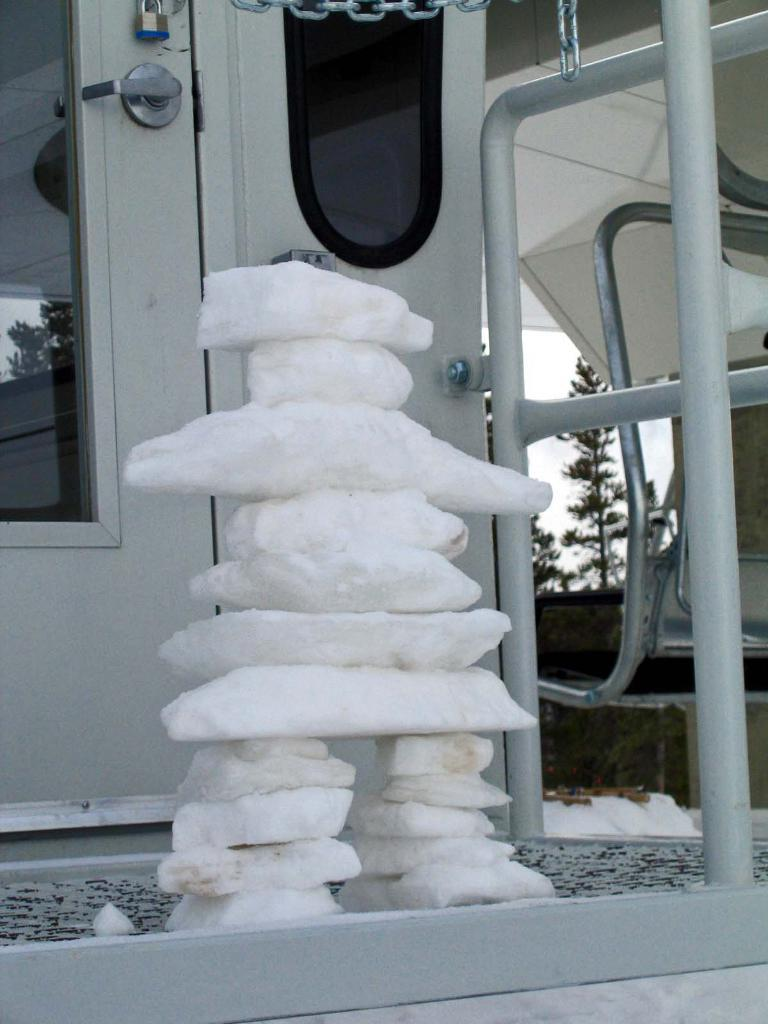What type of structure is visible in the image? There is a structure made of stones in the image. What security features can be seen in the background of the image? There is a lock, a door with a handle, and a chain visible in the background of the image. What other objects are present in the background of the image? There is a grill and trees visible in the background of the image. What type of surface is visible in the background of the image? There is a floor visible in the background of the image. What can be seen in the sky in the background of the image? The sky is visible in the background of the image. What type of vegetable is growing on the stone structure in the image? There are no vegetables visible on the stone structure in the image. How does the zebra interact with the lock in the background of the image? There is no zebra present in the image, so it cannot interact with the lock. 